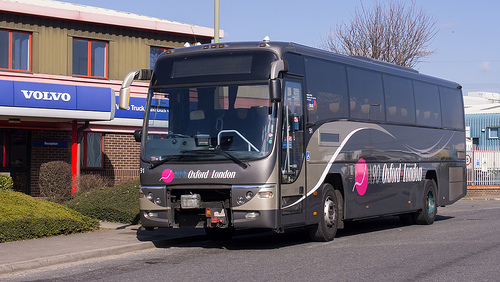Please provide a short description for this region: [0.63, 0.58, 0.68, 0.7]. This region displays a well-maintained, black tire mounted on a silver rim, possibly for a large vehicle like a bus, showing minimal wear and situated on clean tarmac. 